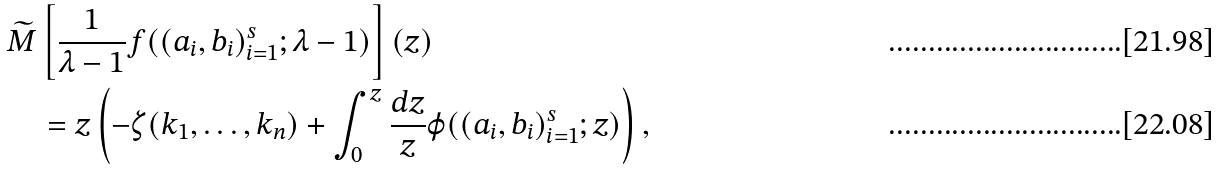<formula> <loc_0><loc_0><loc_500><loc_500>& \widetilde { M } \left [ \frac { 1 } { \lambda - 1 } f ( ( a _ { i } , b _ { i } ) _ { i = 1 } ^ { s } ; \lambda - 1 ) \right ] ( z ) \\ & \quad = z \left ( - \zeta ( k _ { 1 } , \dots , k _ { n } ) + \int _ { 0 } ^ { z } \frac { d z } { z } \varphi ( ( a _ { i } , b _ { i } ) _ { i = 1 } ^ { s } ; z ) \right ) ,</formula> 